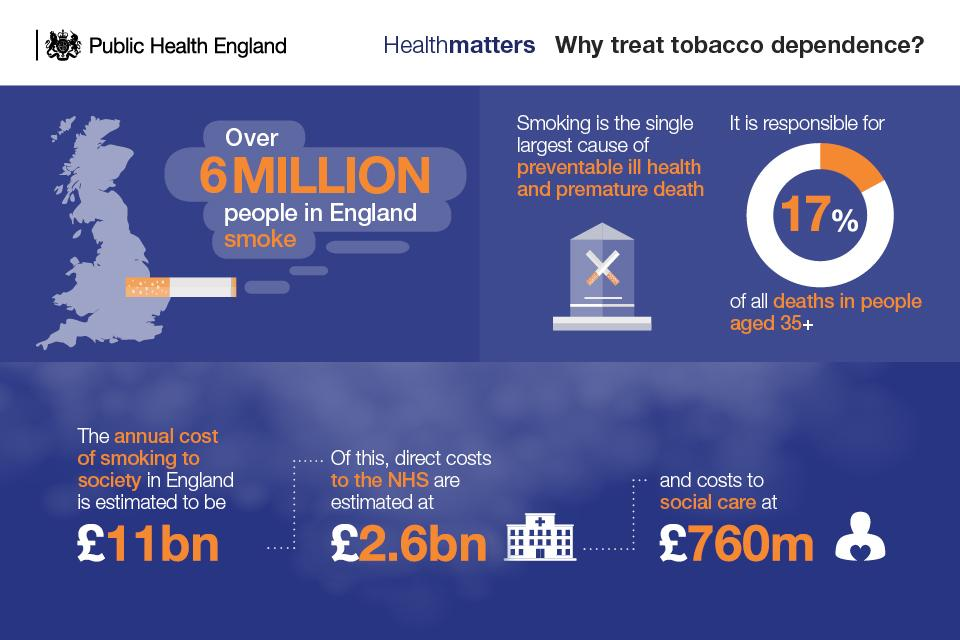Highlight a few significant elements in this photo. The cost incurred directly to the National Health Service due to smoking is 2.6 billion pounds. 